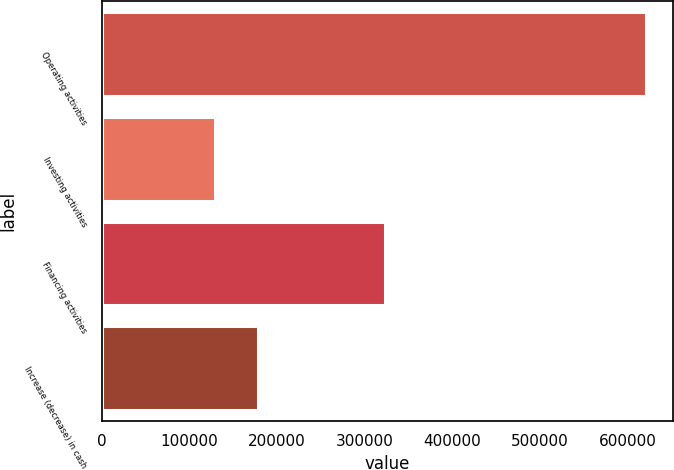Convert chart. <chart><loc_0><loc_0><loc_500><loc_500><bar_chart><fcel>Operating activities<fcel>Investing activities<fcel>Financing activities<fcel>Increase (decrease) in cash<nl><fcel>620738<fcel>129112<fcel>323063<fcel>178275<nl></chart> 